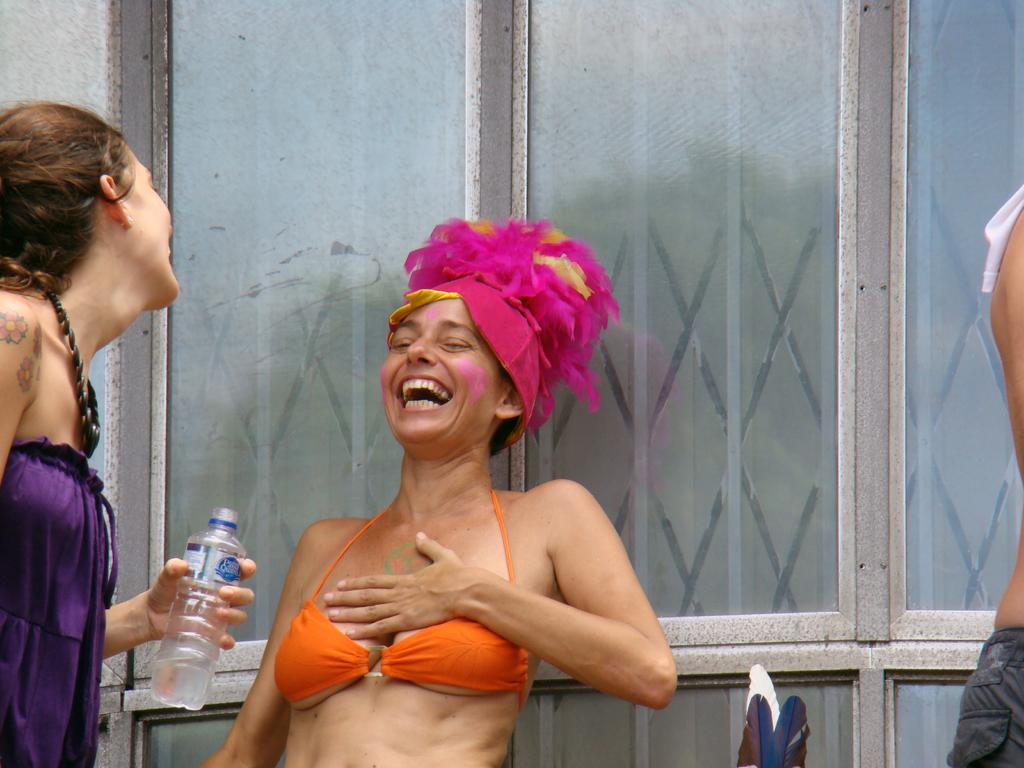How many people are in the image? There are people in the image, but the exact number is not specified. What is the woman in the image doing? A woman is laughing in the image. What is the woman wearing on her head? The woman is wearing a hat. What is the other woman holding in the image? The other woman is holding a bottle in the image. Can you describe an object visible in the background of the image? There is a glass visible in the background of the image. What type of crate is being used to transport the road in the image? There is no crate or road present in the image. 